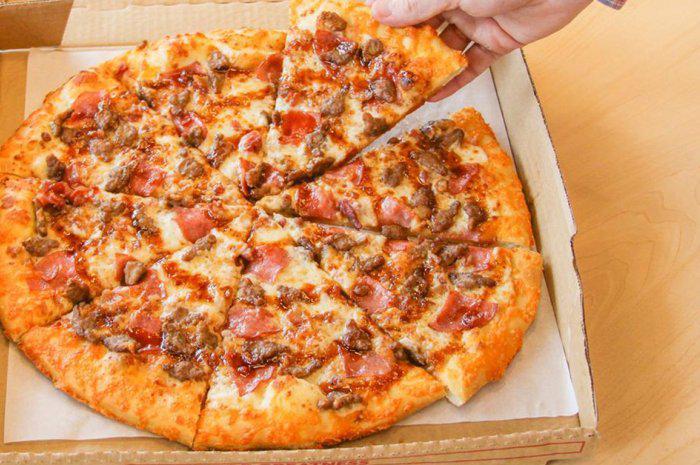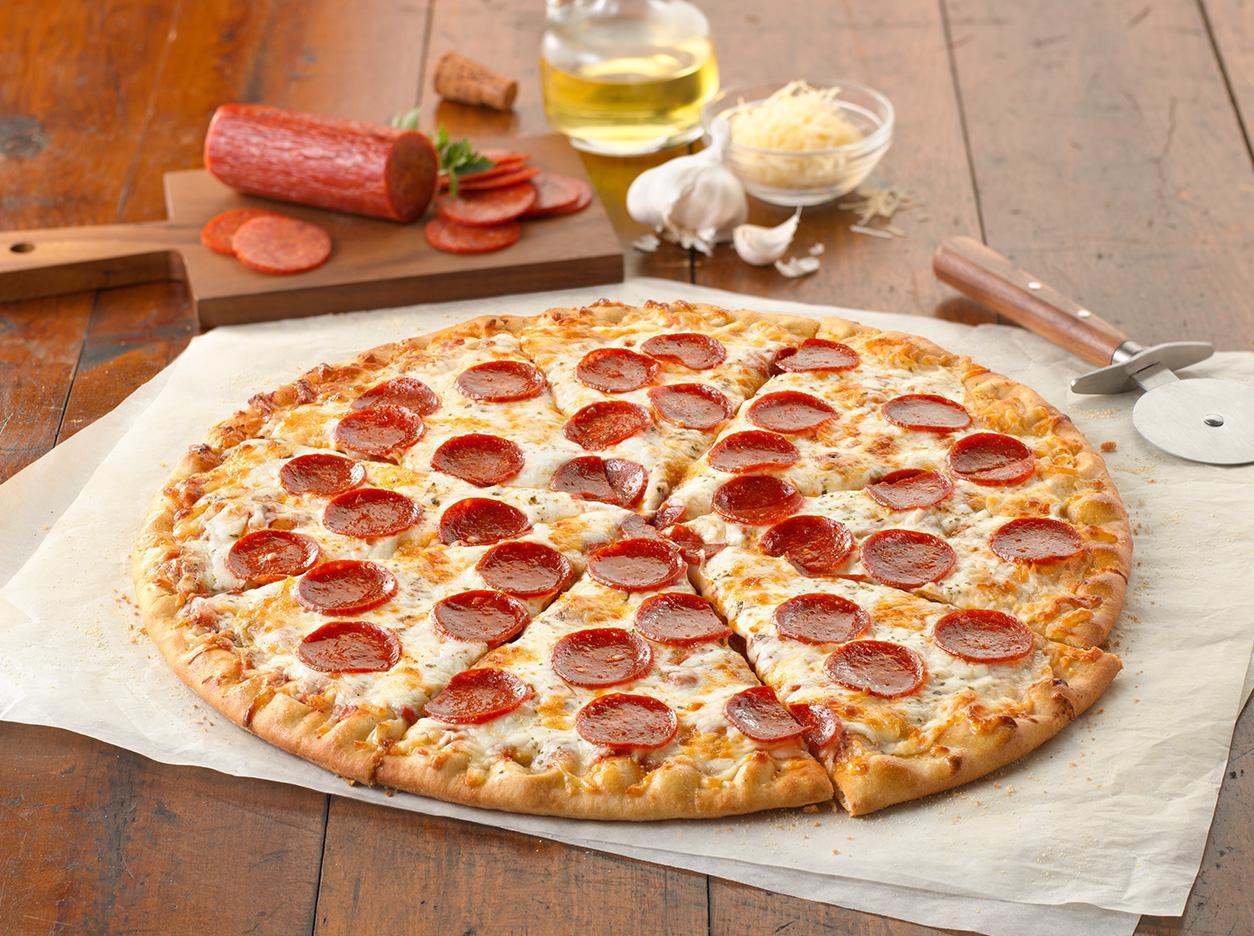The first image is the image on the left, the second image is the image on the right. Given the left and right images, does the statement "Each image shows a full round pizza." hold true? Answer yes or no. Yes. The first image is the image on the left, the second image is the image on the right. Evaluate the accuracy of this statement regarding the images: "One of the pizzas has no other toppings but cheese.". Is it true? Answer yes or no. No. 